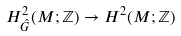Convert formula to latex. <formula><loc_0><loc_0><loc_500><loc_500>H _ { \hat { G } } ^ { 2 } ( M ; \mathbb { Z } ) \rightarrow H ^ { 2 } ( M ; \mathbb { Z } )</formula> 